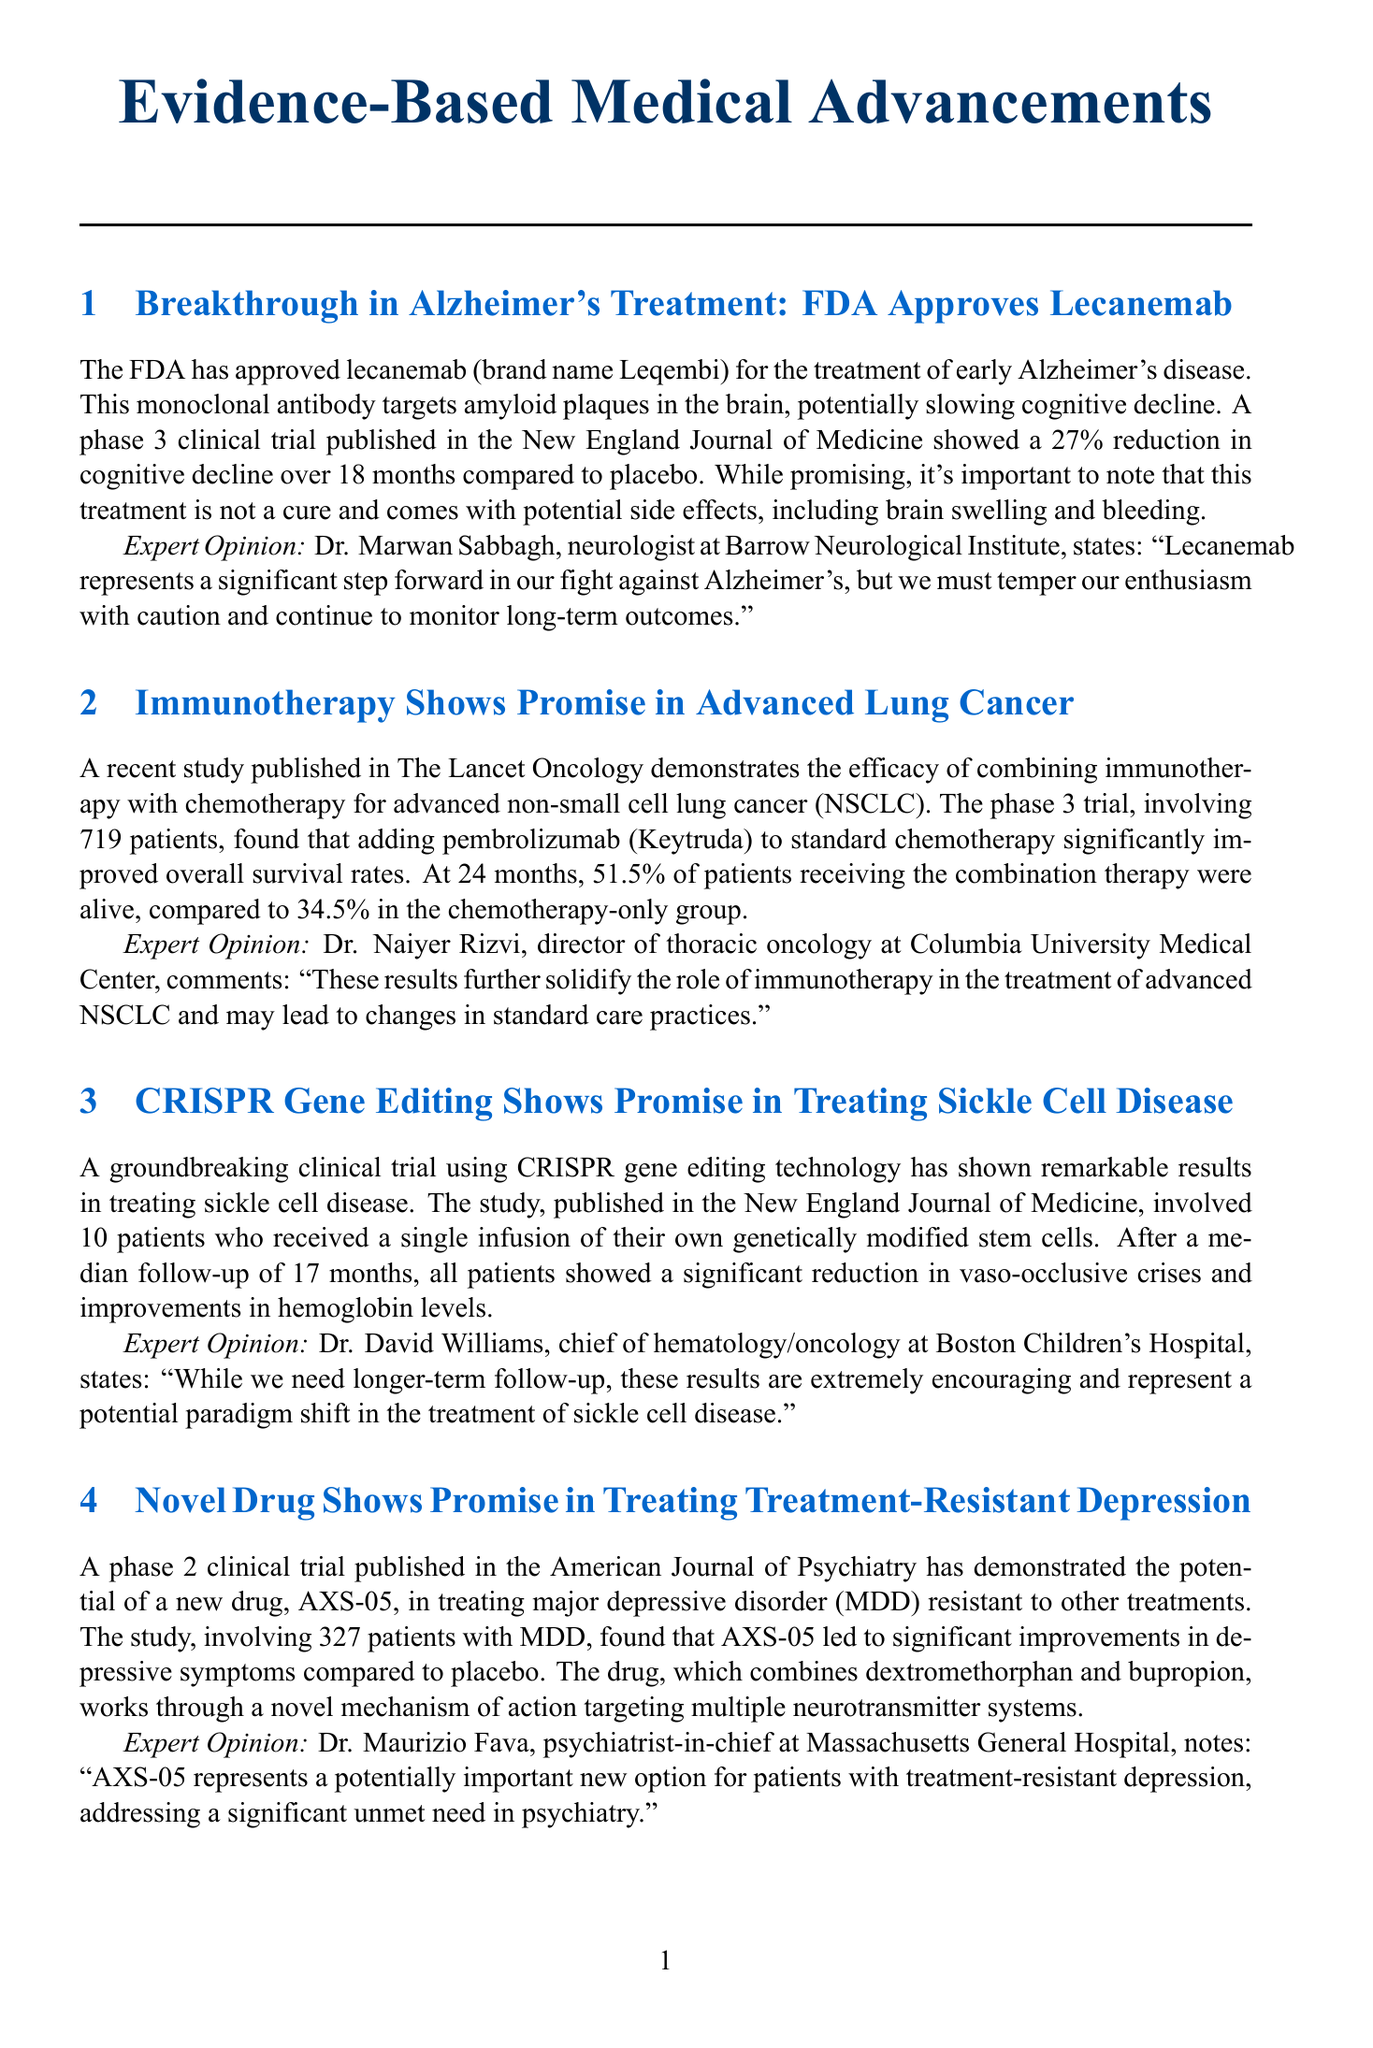What is the brand name of lecanemab? The brand name of lecanemab is Leqembi.
Answer: Leqembi What percentage reduction in cognitive decline was observed with lecanemab? The phase 3 clinical trial showed a 27% reduction in cognitive decline over 18 months compared to placebo.
Answer: 27% How many patients were involved in the lung cancer study? The study involved 719 patients.
Answer: 719 patients What is the novel drug mentioned for treatment-resistant depression? The novel drug mentioned is AXS-05.
Answer: AXS-05 What significant reduction did AI achieve in false negatives for breast cancer detection? The AI reduced false negatives by 9.4% compared to human experts.
Answer: 9.4% What method does AXS-05 target in the brain? AXS-05 works through a novel mechanism of action targeting multiple neurotransmitter systems.
Answer: Multiple neurotransmitter systems Who provided an opinion on the implications of AI in breast cancer detection? Dr. Mozziyar Etemadi provided an opinion on the implications of AI.
Answer: Dr. Mozziyar Etemadi What is the duration of follow-up for CRISPR gene editing study in sickle cell disease? The median follow-up was 17 months.
Answer: 17 months 